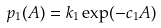<formula> <loc_0><loc_0><loc_500><loc_500>p _ { 1 } ( A ) = k _ { 1 } \exp ( - c _ { 1 } A )</formula> 